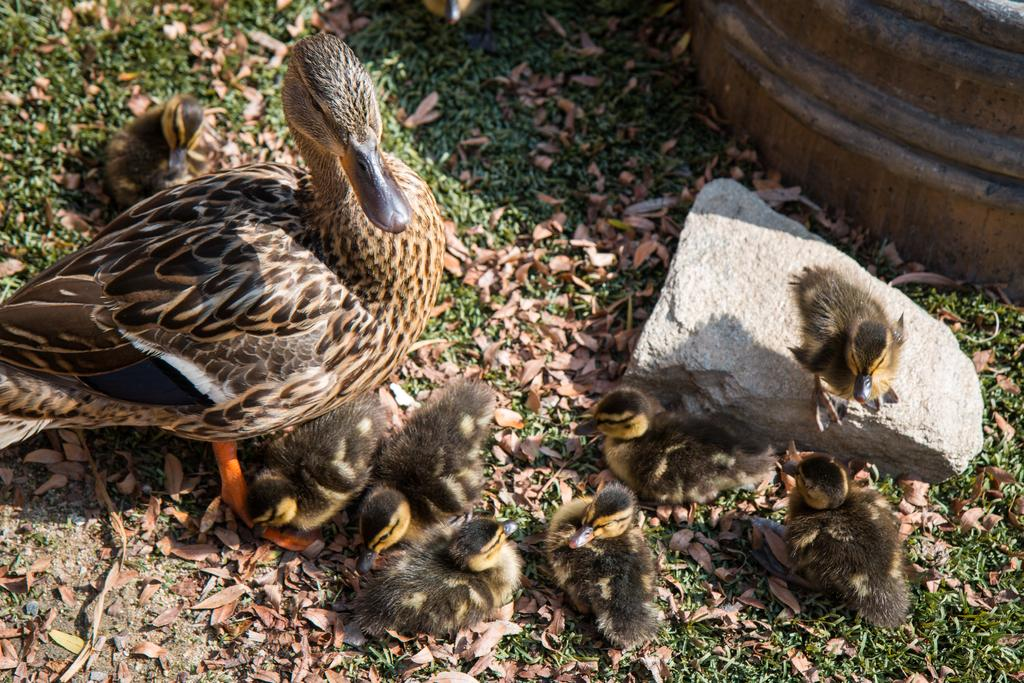What type of animal is present in the image? There is a duck in the image. Are there any other animals related to the duck in the image? Yes, there are ducklings in the image. What is the setting of the image? The scene takes place on green land. Can you describe the position of one of the ducklings? One duckling is on a stone. What else can be seen beside the stone? There is an object beside the stone. Can you hear the ducklings laughing in the image? There is no sound in the image, so it is not possible to hear the ducklings laughing. 